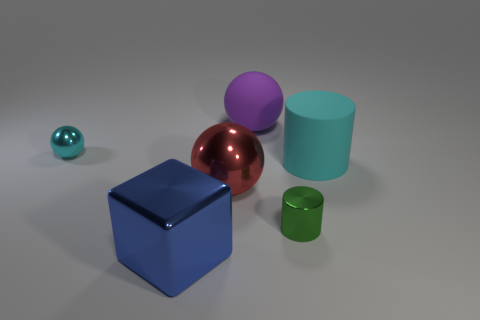Subtract all tiny shiny spheres. How many spheres are left? 2 Subtract all red balls. How many balls are left? 2 Add 3 large purple things. How many objects exist? 9 Subtract 1 cylinders. How many cylinders are left? 1 Subtract all cyan blocks. Subtract all cyan cylinders. How many blocks are left? 1 Subtract all blue balls. How many green cylinders are left? 1 Subtract all red objects. Subtract all rubber spheres. How many objects are left? 4 Add 5 green metallic cylinders. How many green metallic cylinders are left? 6 Add 2 large rubber cylinders. How many large rubber cylinders exist? 3 Subtract 0 gray balls. How many objects are left? 6 